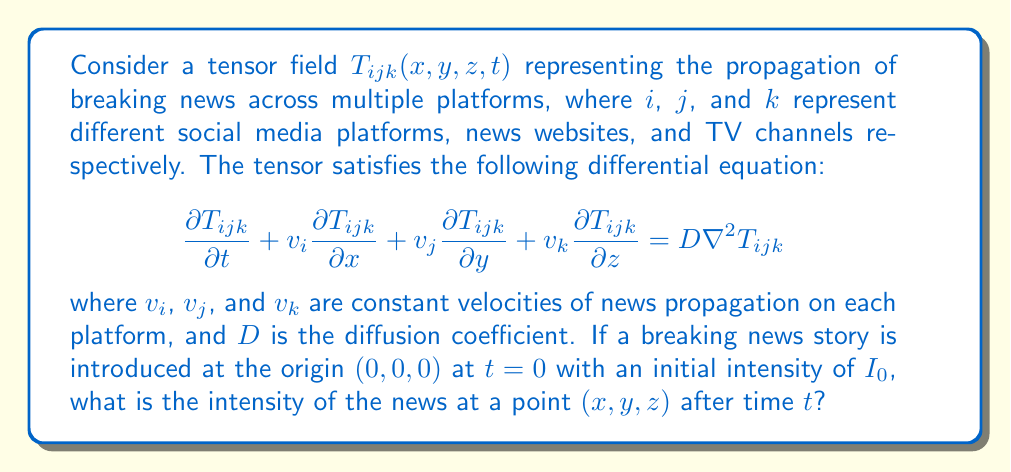Provide a solution to this math problem. To solve this problem, we'll follow these steps:

1) The given equation is a tensor-based advection-diffusion equation. For a point source at the origin, we can use the solution of the 3D diffusion equation with advection.

2) The solution for such an equation with a point source is:

   $$T_{ijk}(x,y,z,t) = \frac{I_0}{(4\pi Dt)^{3/2}} \exp\left(-\frac{(x-v_it)^2 + (y-v_jt)^2 + (z-v_kt)^2}{4Dt}\right)$$

3) This solution represents the intensity of the news at any point $(x,y,z)$ at time $t$, considering the propagation velocities on each platform and the diffusion of information.

4) The exponential term accounts for the spatial spread and the advection (movement) of the news, while the prefactor accounts for the conservation of the total intensity.

5) Note that as $t$ increases, the news spreads out (due to the $t^{3/2}$ term in the denominator), but also moves in the direction of the velocities $v_i$, $v_j$, and $v_k$.

6) This solution assumes that the news propagates independently on each platform, but the overall intensity is a combination of all platforms, represented by the tensor indices $i$, $j$, and $k$.
Answer: $$T_{ijk}(x,y,z,t) = \frac{I_0}{(4\pi Dt)^{3/2}} \exp\left(-\frac{(x-v_it)^2 + (y-v_jt)^2 + (z-v_kt)^2}{4Dt}\right)$$ 